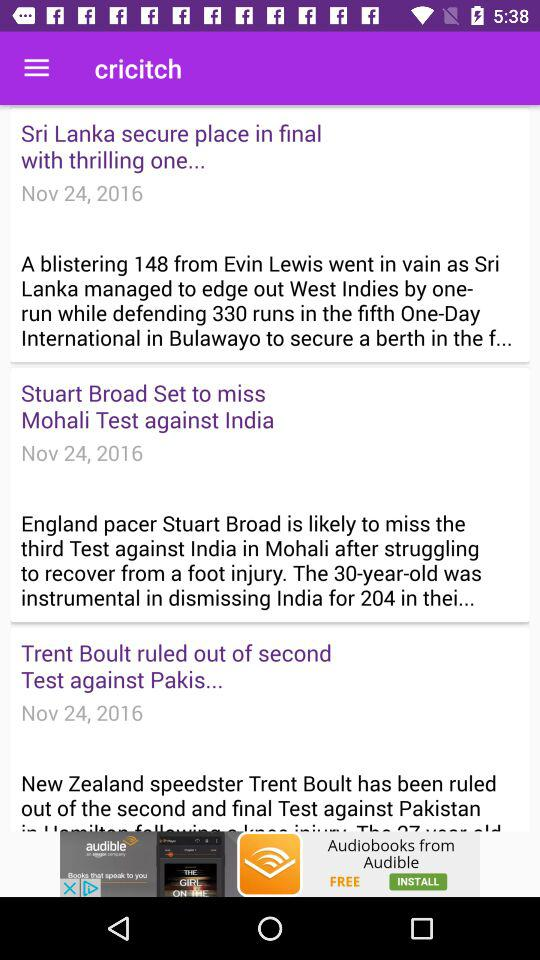What was the score for "New Zealand" in the first and second innings? The scores for "New Zealand" in the first and second innings were 271/10 and 313/5 d, respectively. 